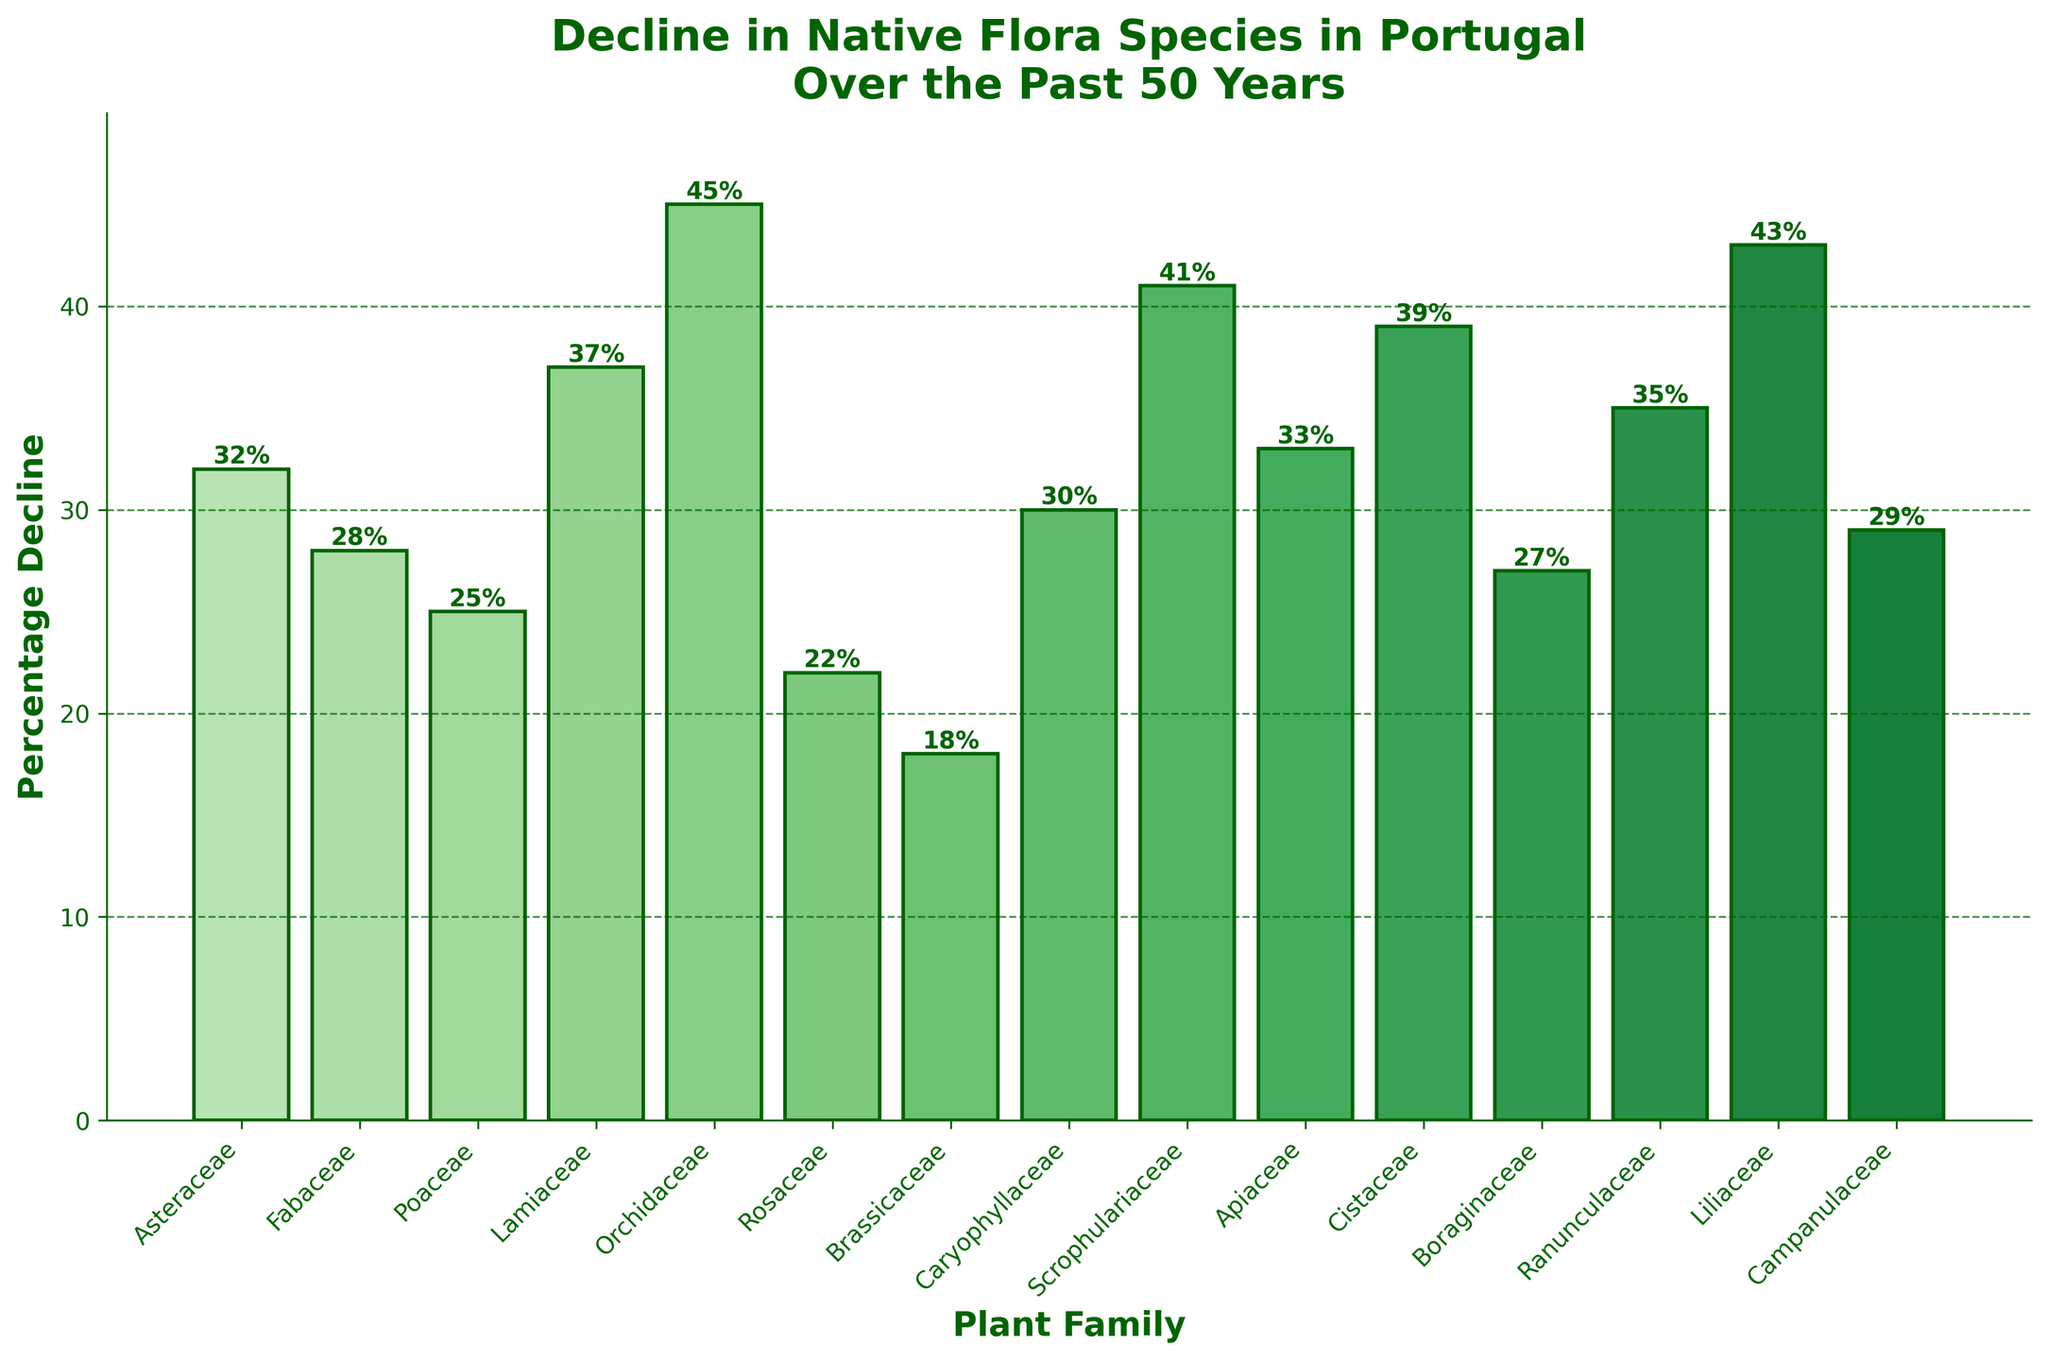Which plant family has experienced the highest percentage decline in native flora species in Portugal over the past 50 years? To find the family with the highest percentage decline, look for the tallest bar in the bar chart. The Orchidaceae family has the tallest bar at 45%.
Answer: Orchidaceae Which plant family has experienced the lowest percentage decline in native flora species in Portugal over the past 50 years? To determine the family with the lowest percentage decline, look for the shortest bar in the bar chart. The Brassicaceae family has the shortest bar at 18%.
Answer: Brassicaceae How does the percentage decline of the Liliaceae family compare to the average percentage decline of all families? First, calculate the average percentage decline by summing all decline values and dividing by the number of families. Total decline sum: 535. Number of families: 15. Average decline: 535 / 15 = 35.67%. The Liliaceae family has a decline of 43%, which is above the average.
Answer: Above the average What is the combined percentage decline of the top three plant families with the highest declines? Identify the top three families: Orchidaceae (45%), Liliaceae (43%), Scrophulariaceae (41%). Add these declines together: 45% + 43% + 41% = 129%.
Answer: 129% Which families have a percentage decline greater than 35%? Identify families with declines above 35% by noting the bars taller than that height. They are: Lamiaceae (37%), Orchidaceae (45%), Scrophulariaceae (41%), Cistaceae (39%), Ranunculaceae (35.67%), Liliaceae (43%).
Answer: Lamiaceae, Orchidaceae, Scrophulariaceae, Cistaceae, Ranunculaceae, Liliaceae What is the difference in percentage decline between the Fabaceae and Poaceae families? Subtract the percentage decline of Poaceae from that of Fabaceae. Fabaceae: 28%, Poaceae: 25%. Difference: 28% - 25% = 3%.
Answer: 3% In terms of visual height, how does the bar for Apiaceae compare to that for Fabaceae? Compare the height of the Apiaceae bar to the Fabaceae bar. Apiaceae has a 33% decline and Fabaceae has a 28% decline; the Apiaceae bar is visually taller.
Answer: Taller Are there more families with a decline above or below 30%? Count the families with declines above and below 30%. Above 30%: Asteraceae, Lamiaceae, Orchidaceae, Caryophyllaceae, Scrophulariaceae, Apiaceae, Cistaceae, Ranunculaceae, Liliaceae (9 families). Below 30%: Fabaceae, Poaceae, Rosaceae, Brassicaceae, Boraginaceae, Campanulaceae (6 families). More families have a decline above 30%.
Answer: Above What is the median percentage decline across all plant families? Arrange declines in ascending order and find the middle value(s). Decline values: 18%, 22%, 25%, 27%, 28%, 29%, 30%, 32%, 33%, 35%, 37%, 39%, 41%, 43%, 45%. The middle value is at the 8th position: 32%.
Answer: 32% Which family has a visual bar color that appears the darkest among the listed family declines? Identify the family with the highest decline since the colors are gradient based on decline values. The Orchidaceae family has the darkest bar due to the highest percentage decline of 45%.
Answer: Orchidaceae 